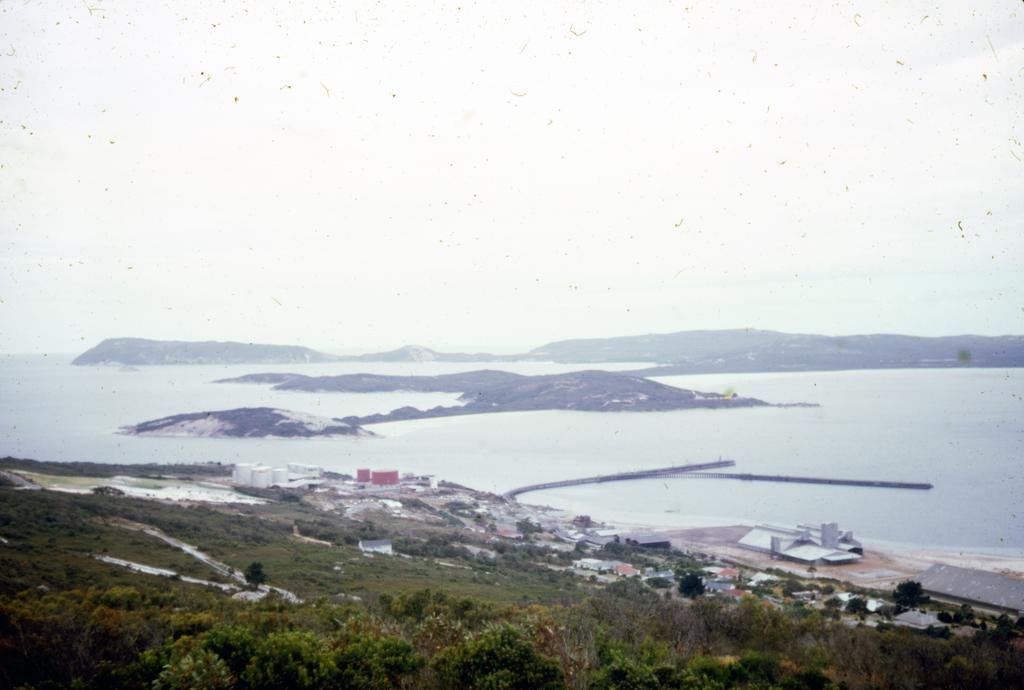What is located at the bottom of the image? There are buildings, trees, and grass at the bottom of the image. What can be seen in the background of the image? There is a river and mountains in the background of the image. What is visible at the top of the image? The sky is visible at the top of the image. How many legs can be seen on the brick in the image? There is no brick present in the image, and therefore no legs can be seen on it. What is the level of quietness in the image? The concept of quietness cannot be determined from the image, as it only contains visual information. 